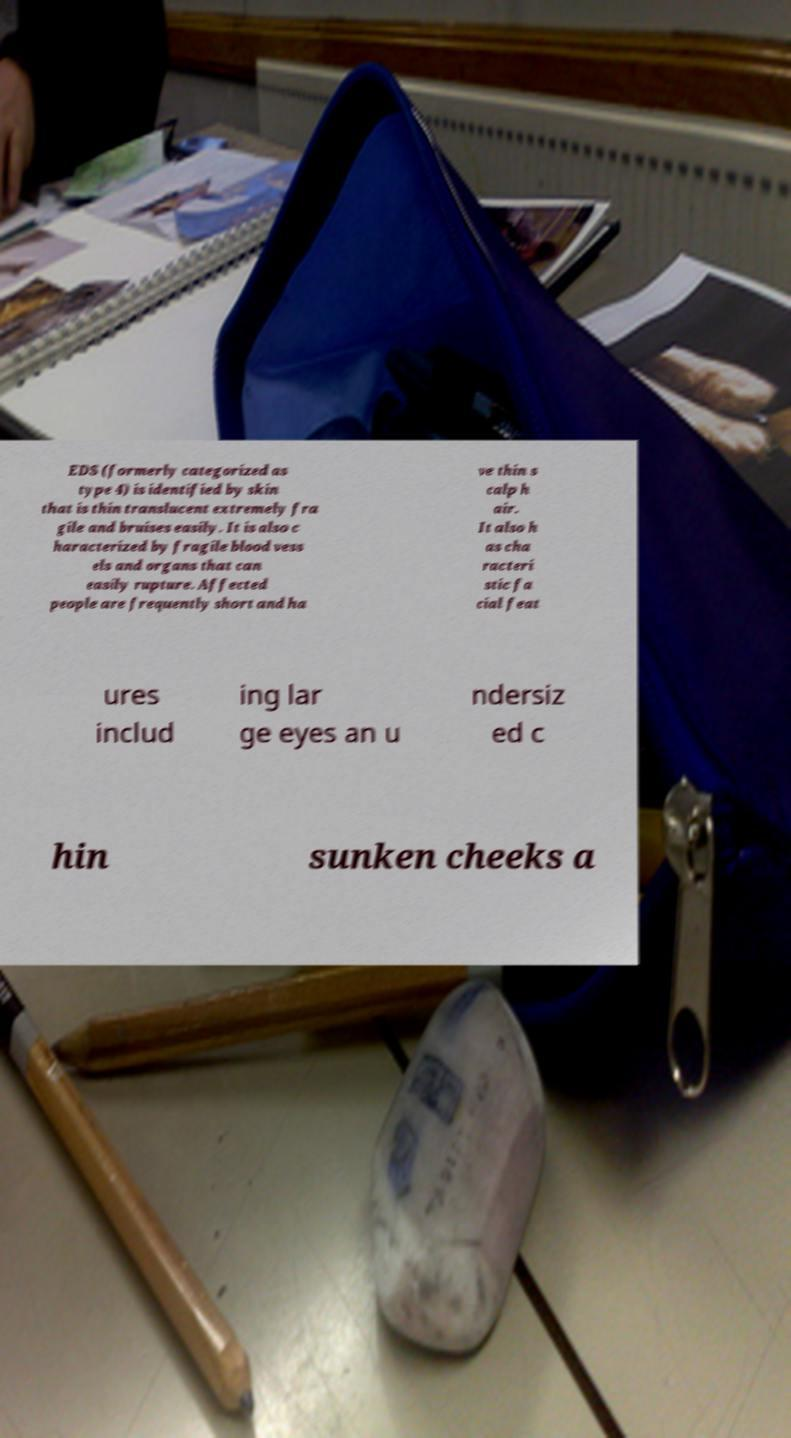What messages or text are displayed in this image? I need them in a readable, typed format. EDS (formerly categorized as type 4) is identified by skin that is thin translucent extremely fra gile and bruises easily. It is also c haracterized by fragile blood vess els and organs that can easily rupture. Affected people are frequently short and ha ve thin s calp h air. It also h as cha racteri stic fa cial feat ures includ ing lar ge eyes an u ndersiz ed c hin sunken cheeks a 